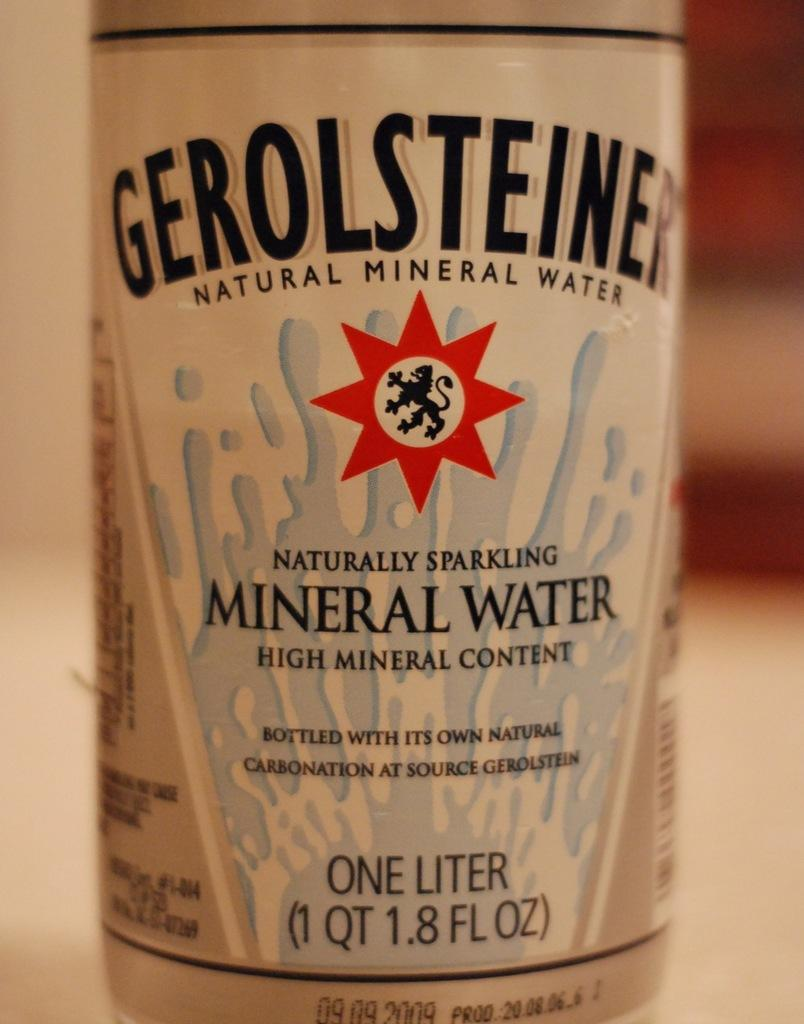What is the main object in the center of the image? There is a bottle in the center of the image. What can be found on the bottle? There is text on the bottle. How would you describe the background of the image? The background of the image is blurred. What grade did the person receive for their protest suit in the image? There is no protest or suit present in the image; it only features a bottle with text and a blurred background. 